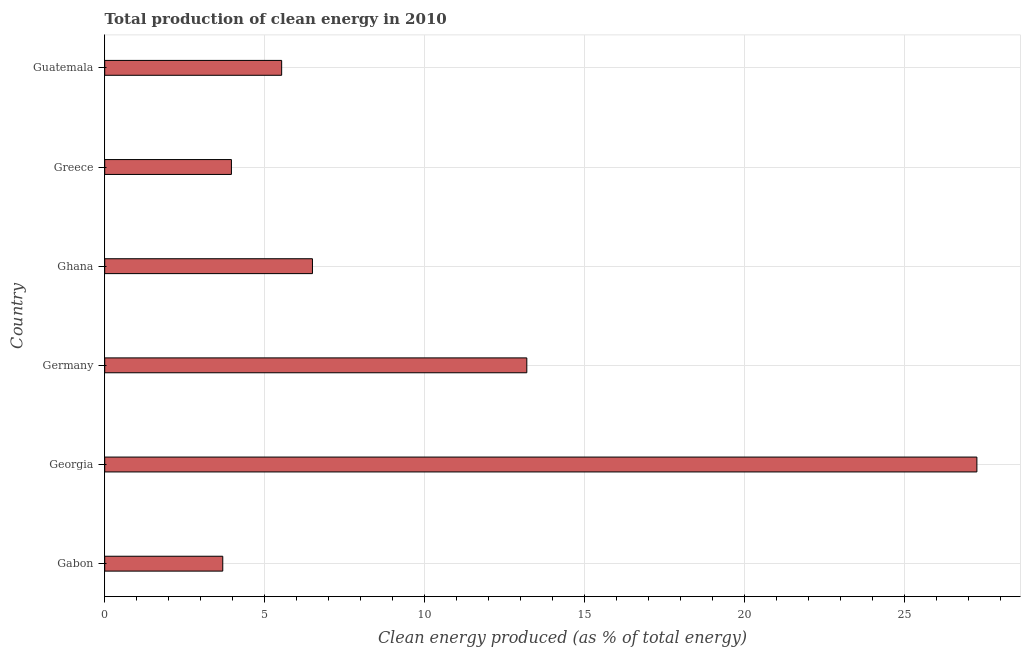Does the graph contain any zero values?
Provide a short and direct response. No. Does the graph contain grids?
Ensure brevity in your answer.  Yes. What is the title of the graph?
Give a very brief answer. Total production of clean energy in 2010. What is the label or title of the X-axis?
Your answer should be compact. Clean energy produced (as % of total energy). What is the production of clean energy in Ghana?
Offer a very short reply. 6.5. Across all countries, what is the maximum production of clean energy?
Your answer should be compact. 27.27. Across all countries, what is the minimum production of clean energy?
Keep it short and to the point. 3.69. In which country was the production of clean energy maximum?
Keep it short and to the point. Georgia. In which country was the production of clean energy minimum?
Your answer should be very brief. Gabon. What is the sum of the production of clean energy?
Offer a very short reply. 60.15. What is the difference between the production of clean energy in Gabon and Georgia?
Offer a terse response. -23.58. What is the average production of clean energy per country?
Offer a terse response. 10.02. What is the median production of clean energy?
Your answer should be compact. 6.01. What is the ratio of the production of clean energy in Gabon to that in Greece?
Keep it short and to the point. 0.93. Is the production of clean energy in Greece less than that in Guatemala?
Your answer should be very brief. Yes. What is the difference between the highest and the second highest production of clean energy?
Give a very brief answer. 14.07. What is the difference between the highest and the lowest production of clean energy?
Provide a succinct answer. 23.58. How many bars are there?
Offer a terse response. 6. How many countries are there in the graph?
Provide a short and direct response. 6. What is the difference between two consecutive major ticks on the X-axis?
Offer a very short reply. 5. Are the values on the major ticks of X-axis written in scientific E-notation?
Keep it short and to the point. No. What is the Clean energy produced (as % of total energy) of Gabon?
Your answer should be very brief. 3.69. What is the Clean energy produced (as % of total energy) of Georgia?
Give a very brief answer. 27.27. What is the Clean energy produced (as % of total energy) in Germany?
Your answer should be compact. 13.2. What is the Clean energy produced (as % of total energy) in Ghana?
Provide a short and direct response. 6.5. What is the Clean energy produced (as % of total energy) in Greece?
Give a very brief answer. 3.96. What is the Clean energy produced (as % of total energy) in Guatemala?
Ensure brevity in your answer.  5.53. What is the difference between the Clean energy produced (as % of total energy) in Gabon and Georgia?
Offer a very short reply. -23.58. What is the difference between the Clean energy produced (as % of total energy) in Gabon and Germany?
Provide a succinct answer. -9.51. What is the difference between the Clean energy produced (as % of total energy) in Gabon and Ghana?
Make the answer very short. -2.8. What is the difference between the Clean energy produced (as % of total energy) in Gabon and Greece?
Your response must be concise. -0.27. What is the difference between the Clean energy produced (as % of total energy) in Gabon and Guatemala?
Your answer should be very brief. -1.84. What is the difference between the Clean energy produced (as % of total energy) in Georgia and Germany?
Offer a terse response. 14.07. What is the difference between the Clean energy produced (as % of total energy) in Georgia and Ghana?
Offer a terse response. 20.77. What is the difference between the Clean energy produced (as % of total energy) in Georgia and Greece?
Provide a succinct answer. 23.31. What is the difference between the Clean energy produced (as % of total energy) in Georgia and Guatemala?
Give a very brief answer. 21.74. What is the difference between the Clean energy produced (as % of total energy) in Germany and Ghana?
Ensure brevity in your answer.  6.7. What is the difference between the Clean energy produced (as % of total energy) in Germany and Greece?
Keep it short and to the point. 9.24. What is the difference between the Clean energy produced (as % of total energy) in Germany and Guatemala?
Provide a succinct answer. 7.66. What is the difference between the Clean energy produced (as % of total energy) in Ghana and Greece?
Give a very brief answer. 2.53. What is the difference between the Clean energy produced (as % of total energy) in Ghana and Guatemala?
Keep it short and to the point. 0.96. What is the difference between the Clean energy produced (as % of total energy) in Greece and Guatemala?
Your answer should be compact. -1.57. What is the ratio of the Clean energy produced (as % of total energy) in Gabon to that in Georgia?
Provide a succinct answer. 0.14. What is the ratio of the Clean energy produced (as % of total energy) in Gabon to that in Germany?
Ensure brevity in your answer.  0.28. What is the ratio of the Clean energy produced (as % of total energy) in Gabon to that in Ghana?
Offer a terse response. 0.57. What is the ratio of the Clean energy produced (as % of total energy) in Gabon to that in Greece?
Keep it short and to the point. 0.93. What is the ratio of the Clean energy produced (as % of total energy) in Gabon to that in Guatemala?
Keep it short and to the point. 0.67. What is the ratio of the Clean energy produced (as % of total energy) in Georgia to that in Germany?
Your answer should be very brief. 2.07. What is the ratio of the Clean energy produced (as % of total energy) in Georgia to that in Ghana?
Offer a very short reply. 4.2. What is the ratio of the Clean energy produced (as % of total energy) in Georgia to that in Greece?
Your answer should be compact. 6.88. What is the ratio of the Clean energy produced (as % of total energy) in Georgia to that in Guatemala?
Your answer should be compact. 4.93. What is the ratio of the Clean energy produced (as % of total energy) in Germany to that in Ghana?
Make the answer very short. 2.03. What is the ratio of the Clean energy produced (as % of total energy) in Germany to that in Greece?
Provide a succinct answer. 3.33. What is the ratio of the Clean energy produced (as % of total energy) in Germany to that in Guatemala?
Keep it short and to the point. 2.38. What is the ratio of the Clean energy produced (as % of total energy) in Ghana to that in Greece?
Make the answer very short. 1.64. What is the ratio of the Clean energy produced (as % of total energy) in Ghana to that in Guatemala?
Offer a very short reply. 1.17. What is the ratio of the Clean energy produced (as % of total energy) in Greece to that in Guatemala?
Give a very brief answer. 0.72. 